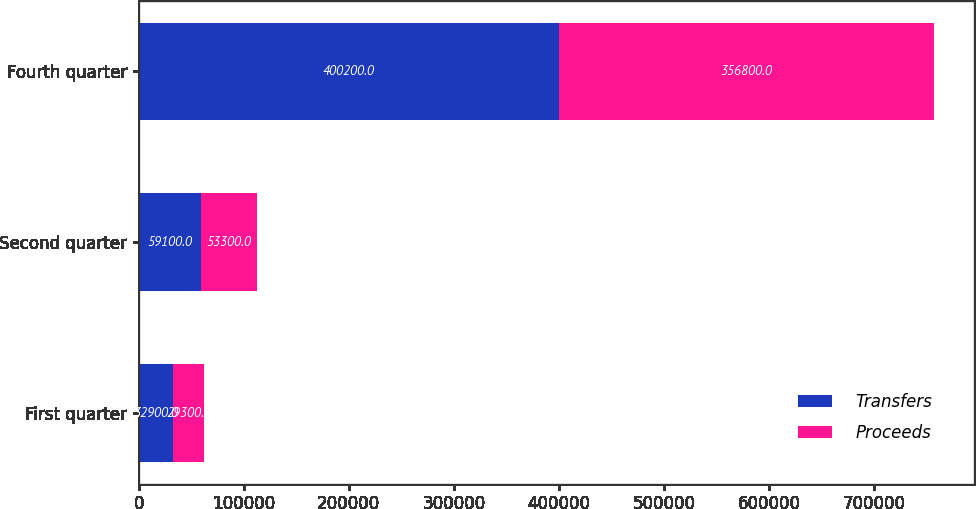Convert chart to OTSL. <chart><loc_0><loc_0><loc_500><loc_500><stacked_bar_chart><ecel><fcel>First quarter<fcel>Second quarter<fcel>Fourth quarter<nl><fcel>Transfers<fcel>32900<fcel>59100<fcel>400200<nl><fcel>Proceeds<fcel>29300<fcel>53300<fcel>356800<nl></chart> 